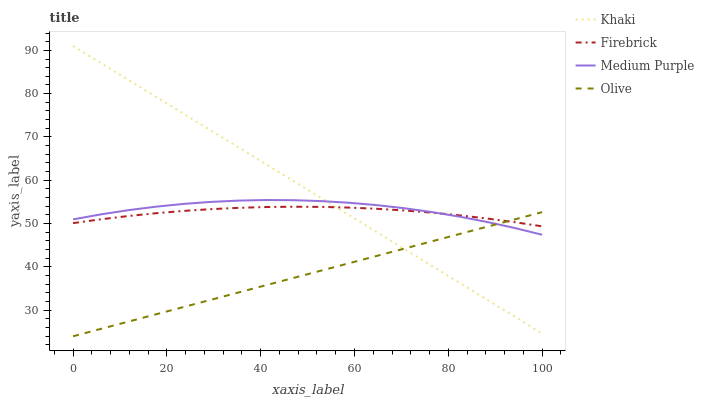Does Olive have the minimum area under the curve?
Answer yes or no. Yes. Does Khaki have the maximum area under the curve?
Answer yes or no. Yes. Does Firebrick have the minimum area under the curve?
Answer yes or no. No. Does Firebrick have the maximum area under the curve?
Answer yes or no. No. Is Olive the smoothest?
Answer yes or no. Yes. Is Medium Purple the roughest?
Answer yes or no. Yes. Is Firebrick the smoothest?
Answer yes or no. No. Is Firebrick the roughest?
Answer yes or no. No. Does Olive have the lowest value?
Answer yes or no. Yes. Does Firebrick have the lowest value?
Answer yes or no. No. Does Khaki have the highest value?
Answer yes or no. Yes. Does Firebrick have the highest value?
Answer yes or no. No. Does Medium Purple intersect Olive?
Answer yes or no. Yes. Is Medium Purple less than Olive?
Answer yes or no. No. Is Medium Purple greater than Olive?
Answer yes or no. No. 